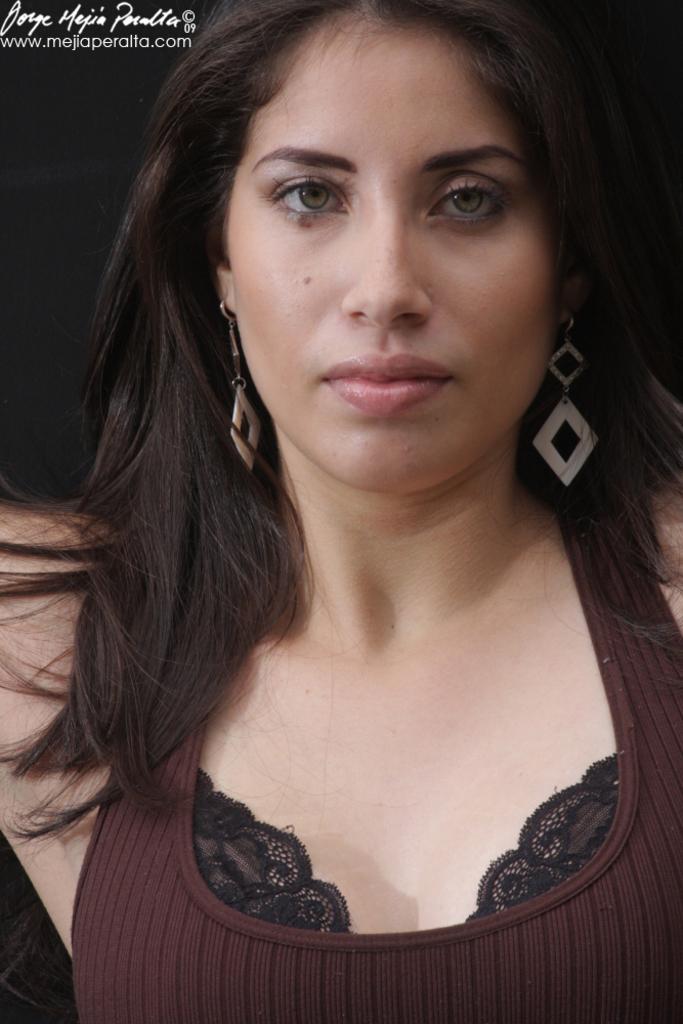Can you describe this image briefly? In this image we can see a lady. 